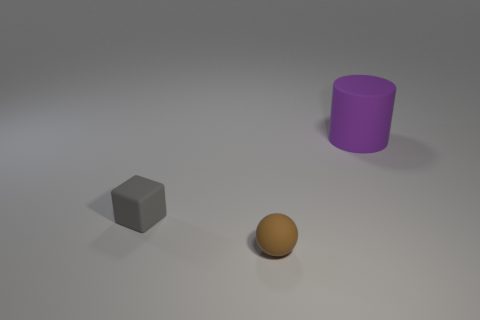What number of things are objects that are to the right of the rubber block or objects that are in front of the gray block?
Your answer should be very brief. 2. Does the brown rubber sphere have the same size as the purple object?
Your answer should be compact. No. Are there more large purple cylinders than green shiny cubes?
Your answer should be compact. Yes. How many other objects are there of the same color as the rubber block?
Offer a terse response. 0. What number of things are either big green things or rubber things?
Make the answer very short. 3. Do the small thing behind the small brown matte thing and the brown thing have the same shape?
Provide a succinct answer. No. What is the color of the rubber object on the right side of the tiny matte thing in front of the gray cube?
Keep it short and to the point. Purple. Are there fewer large red metallic cubes than matte cylinders?
Keep it short and to the point. Yes. Is there another ball made of the same material as the brown ball?
Provide a succinct answer. No. Is the shape of the brown matte thing the same as the tiny object that is left of the brown ball?
Offer a very short reply. No. 